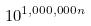Convert formula to latex. <formula><loc_0><loc_0><loc_500><loc_500>1 0 ^ { 1 , 0 0 0 , 0 0 0 n }</formula> 